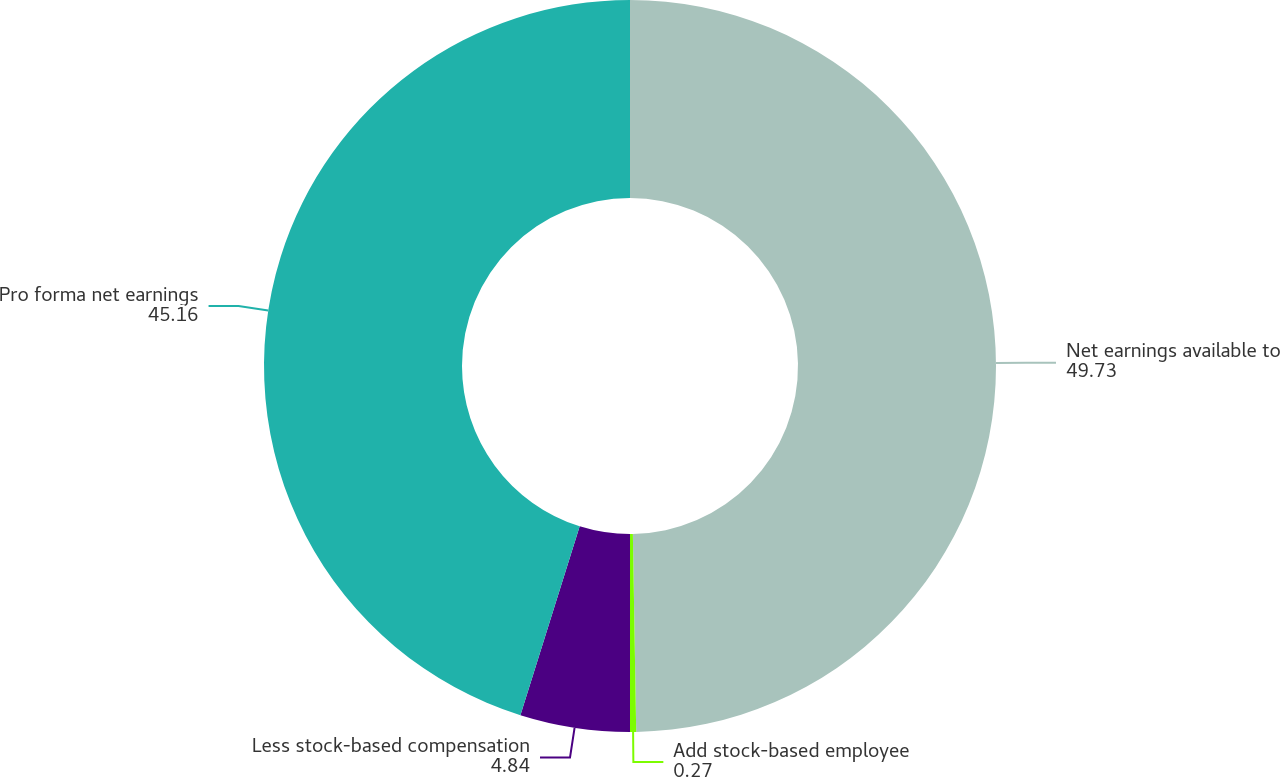Convert chart to OTSL. <chart><loc_0><loc_0><loc_500><loc_500><pie_chart><fcel>Net earnings available to<fcel>Add stock-based employee<fcel>Less stock-based compensation<fcel>Pro forma net earnings<nl><fcel>49.73%<fcel>0.27%<fcel>4.84%<fcel>45.16%<nl></chart> 